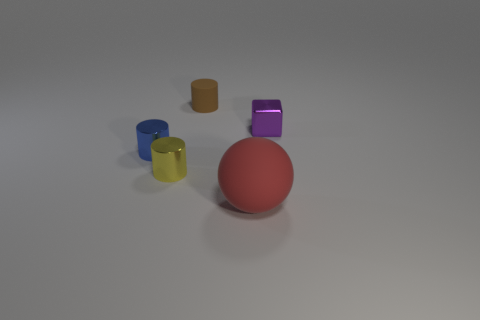Is the number of yellow cylinders that are in front of the cube greater than the number of big gray cylinders?
Provide a succinct answer. Yes. What is the small yellow thing made of?
Your response must be concise. Metal. What number of blue metallic cylinders are the same size as the block?
Offer a very short reply. 1. Are there an equal number of small rubber things that are in front of the red rubber object and matte objects that are in front of the small metallic block?
Ensure brevity in your answer.  No. Do the small cube and the tiny yellow thing have the same material?
Your answer should be very brief. Yes. Is there a tiny brown thing that is behind the small object to the right of the big red matte thing?
Ensure brevity in your answer.  Yes. Is there a small brown object that has the same shape as the tiny yellow shiny object?
Provide a succinct answer. Yes. What is the material of the red thing to the right of the cylinder behind the purple cube?
Keep it short and to the point. Rubber. What size is the rubber sphere?
Your answer should be very brief. Large. The brown cylinder that is the same material as the big sphere is what size?
Make the answer very short. Small. 